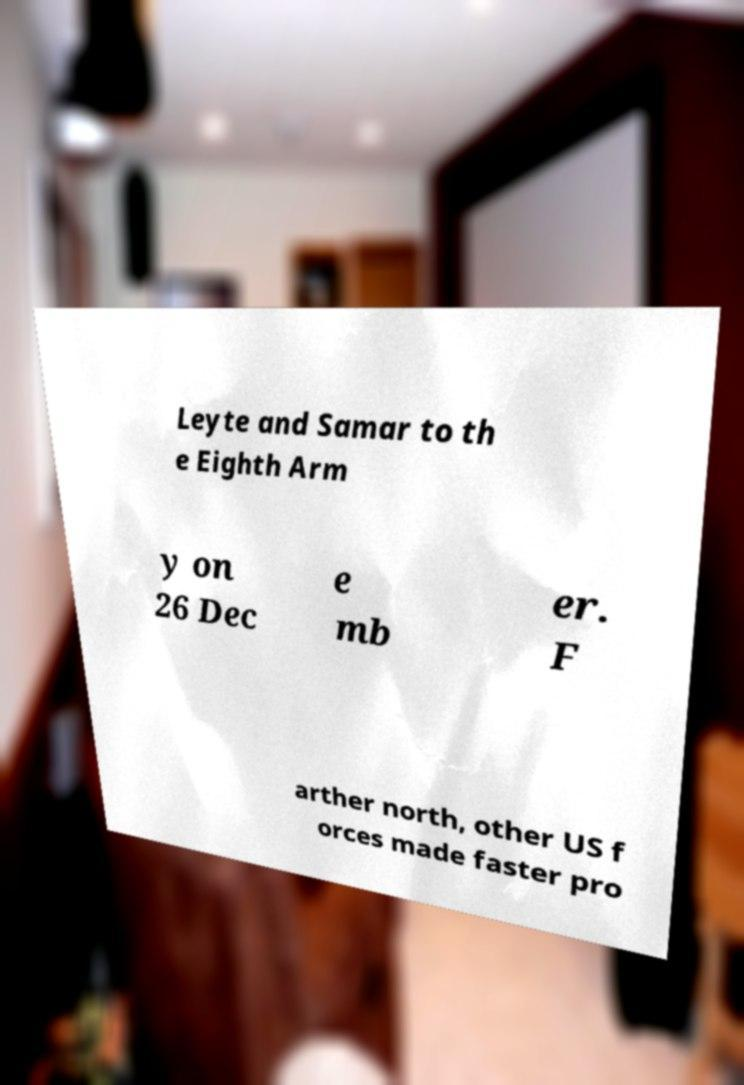There's text embedded in this image that I need extracted. Can you transcribe it verbatim? Leyte and Samar to th e Eighth Arm y on 26 Dec e mb er. F arther north, other US f orces made faster pro 